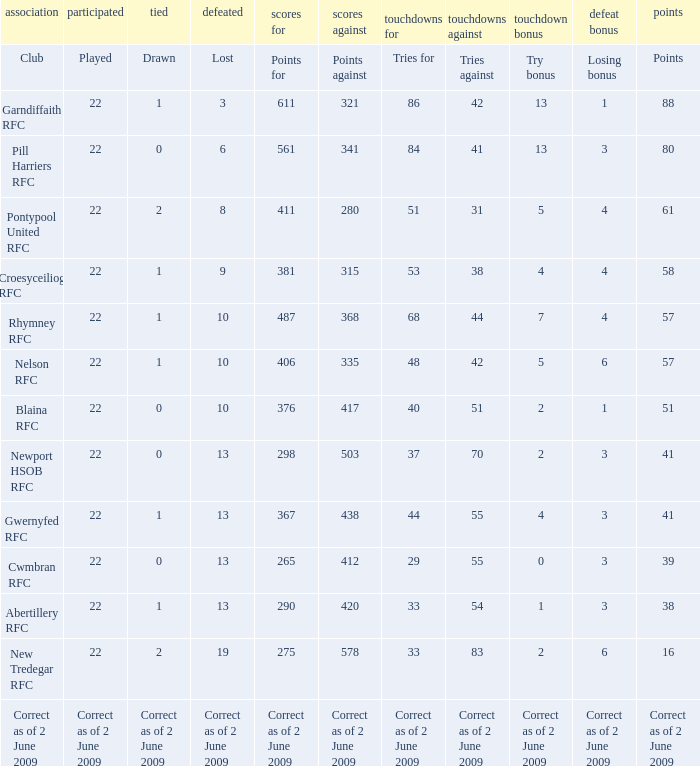How many points against did the club with a losing bonus of 3 and 84 tries have? 341.0. 